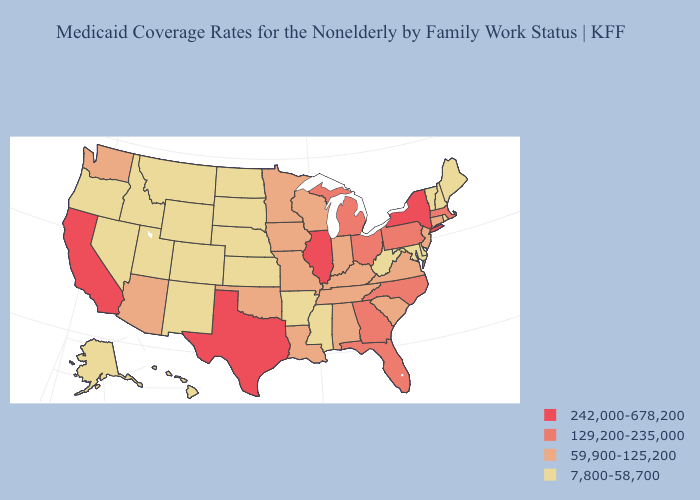What is the lowest value in the USA?
Answer briefly. 7,800-58,700. Is the legend a continuous bar?
Answer briefly. No. Name the states that have a value in the range 129,200-235,000?
Concise answer only. Florida, Georgia, Massachusetts, Michigan, North Carolina, Ohio, Pennsylvania. Which states hav the highest value in the MidWest?
Write a very short answer. Illinois. What is the lowest value in states that border North Carolina?
Be succinct. 59,900-125,200. Does the first symbol in the legend represent the smallest category?
Short answer required. No. What is the lowest value in the USA?
Answer briefly. 7,800-58,700. Among the states that border Washington , which have the lowest value?
Quick response, please. Idaho, Oregon. Name the states that have a value in the range 59,900-125,200?
Write a very short answer. Alabama, Arizona, Connecticut, Indiana, Iowa, Kentucky, Louisiana, Minnesota, Missouri, New Jersey, Oklahoma, South Carolina, Tennessee, Virginia, Washington, Wisconsin. What is the lowest value in the West?
Keep it brief. 7,800-58,700. Does California have the highest value in the West?
Give a very brief answer. Yes. Which states hav the highest value in the MidWest?
Write a very short answer. Illinois. Among the states that border Utah , does Arizona have the highest value?
Short answer required. Yes. Among the states that border Alabama , which have the lowest value?
Write a very short answer. Mississippi. Which states have the lowest value in the South?
Concise answer only. Arkansas, Delaware, Maryland, Mississippi, West Virginia. 